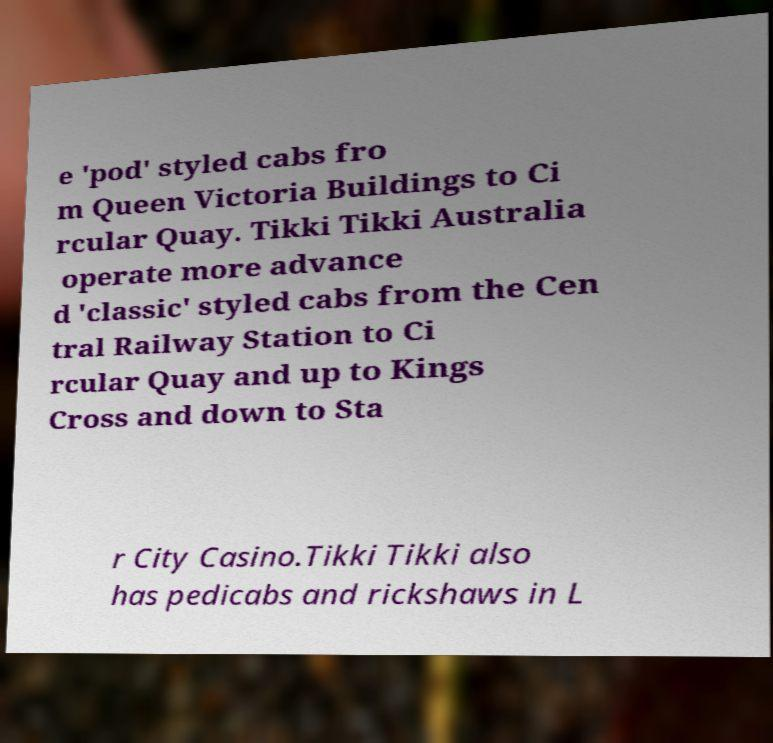Please read and relay the text visible in this image. What does it say? e 'pod' styled cabs fro m Queen Victoria Buildings to Ci rcular Quay. Tikki Tikki Australia operate more advance d 'classic' styled cabs from the Cen tral Railway Station to Ci rcular Quay and up to Kings Cross and down to Sta r City Casino.Tikki Tikki also has pedicabs and rickshaws in L 